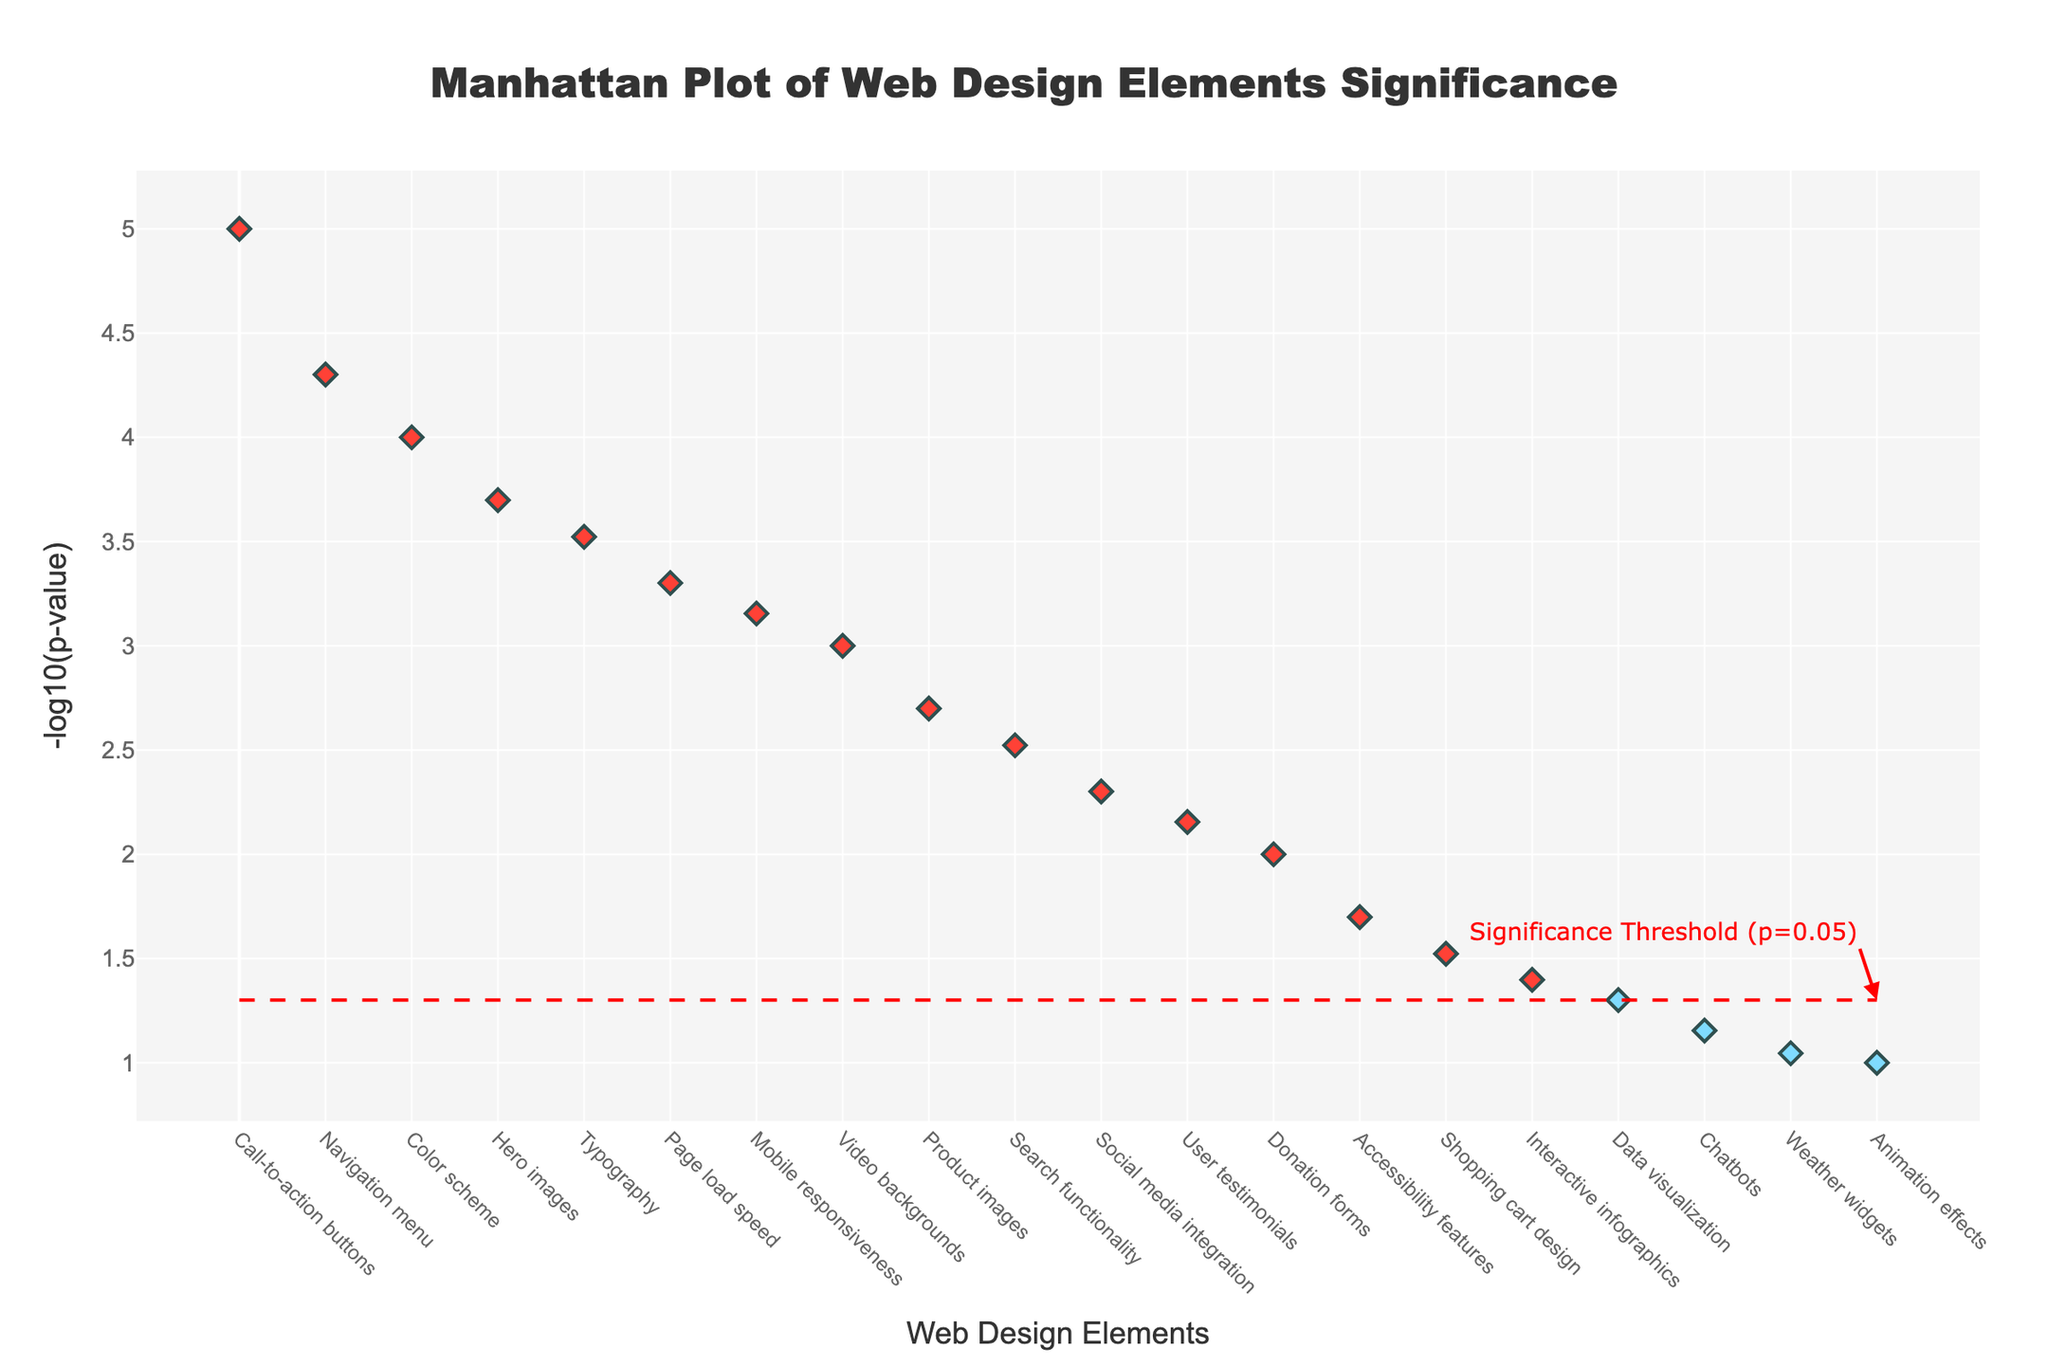Which web design element has the lowest p-value? The element with the lowest p-value appears at the far left of the x-axis with the highest -log10(p) value. This element is for the E-commerce industry, "Call-to-action buttons", with a p-value of 0.00001.
Answer: Call-to-action buttons in E-commerce How many web design elements have a p-value below 0.05? All elements with -log10(p) values above 1.3 (since -log10(0.05) ≈ 1.3) are counted. These are the first 17 elements.
Answer: 17 Which industry has the most statistically significant web design element and what is it? The most statistically significant element has the smallest p-value, represented on the far left with the highest -log10(p) value. This corresponds to the E-commerce industry with "Call-to-action buttons".
Answer: E-commerce, Call-to-action buttons What is the p-value significance threshold represented by the red dashed line? The red dashed line represents the significance threshold where p-value = 0.05.
Answer: 0.05 Is "Accessibility features" in Government above or below the significance threshold? "Accessibility features" is represented by a blue marker for the Government industry. Checking its -log10(p) value against the red dashed line shows it is below the threshold.
Answer: Below Which has a higher -log10(p) value, "Mobile responsiveness" in Travel or "Video backgrounds" in Automotive? Compare the vertical positions of both markers. "Mobile responsiveness" in Travel is higher on the y-axis, indicating a higher -log10(p) value.
Answer: Mobile responsiveness in Travel What feature has the highest -log10(p) value and what does it represent? The highest -log10(p) value is at the top of the y-axis, representing the element for the E-commerce industry, "Call-to-action buttons".
Answer: Call-to-action buttons in E-commerce How many data points are shown on the plot? Count the total number of markers on the plot, which equals the number of rows in the dataset.
Answer: 20 What web design element is suggested as least significant? The element with the lowest -log10(p) value, appearing at the far right of the plot, is "Animation effects" in Entertainment.
Answer: Animation effects in Entertainment 